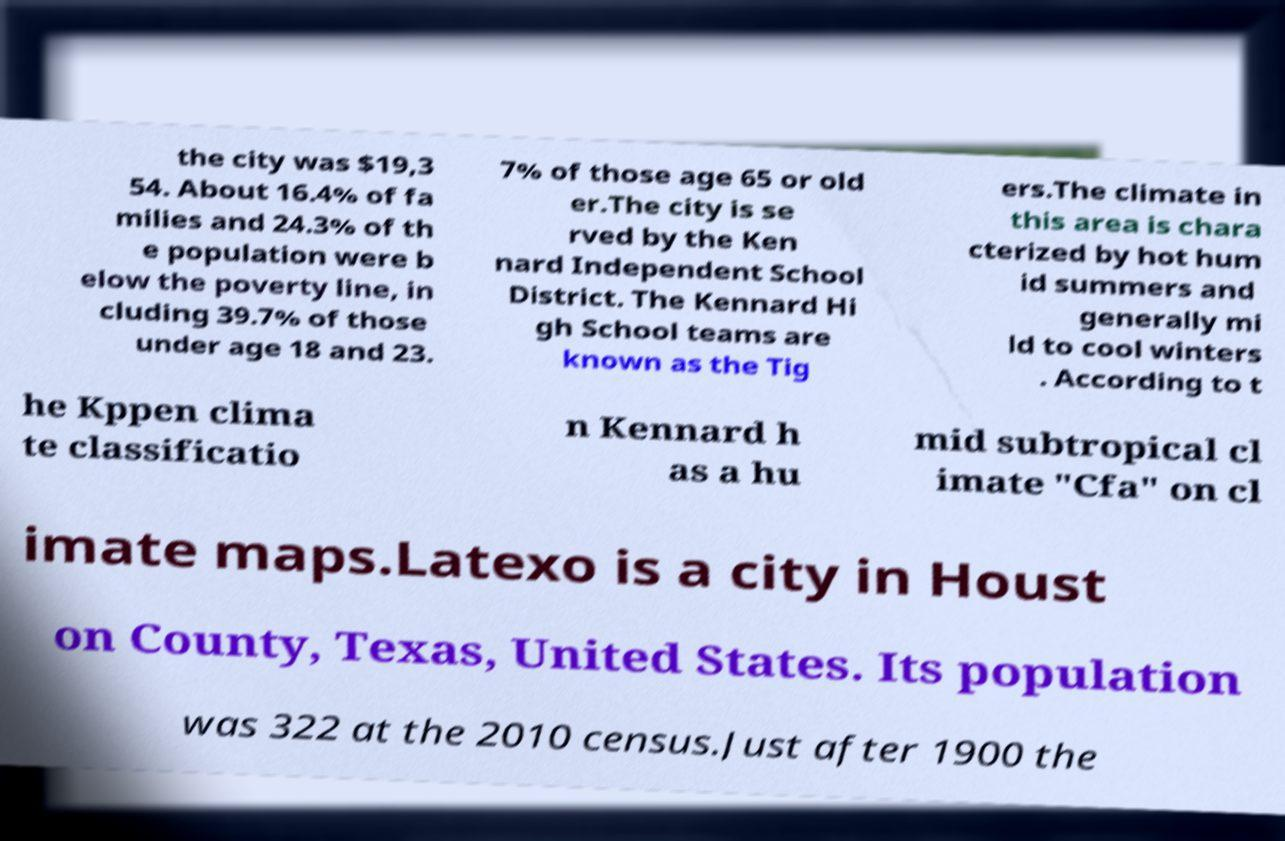Please identify and transcribe the text found in this image. the city was $19,3 54. About 16.4% of fa milies and 24.3% of th e population were b elow the poverty line, in cluding 39.7% of those under age 18 and 23. 7% of those age 65 or old er.The city is se rved by the Ken nard Independent School District. The Kennard Hi gh School teams are known as the Tig ers.The climate in this area is chara cterized by hot hum id summers and generally mi ld to cool winters . According to t he Kppen clima te classificatio n Kennard h as a hu mid subtropical cl imate "Cfa" on cl imate maps.Latexo is a city in Houst on County, Texas, United States. Its population was 322 at the 2010 census.Just after 1900 the 